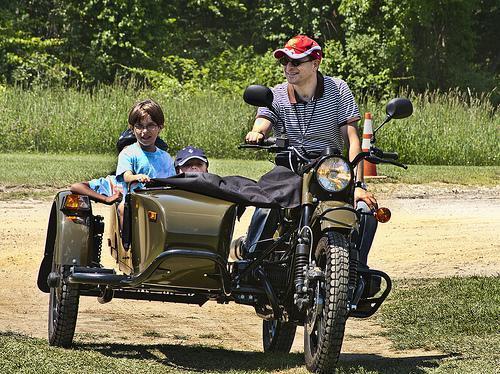How many people are in the sidecar?
Give a very brief answer. 3. 